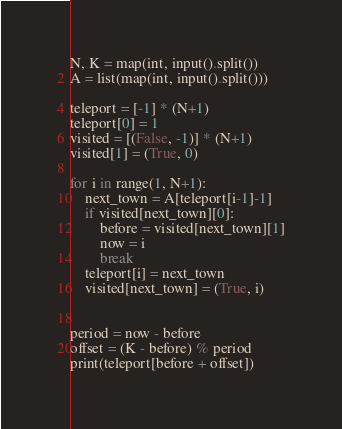Convert code to text. <code><loc_0><loc_0><loc_500><loc_500><_Python_>N, K = map(int, input().split())
A = list(map(int, input().split()))

teleport = [-1] * (N+1)
teleport[0] = 1
visited = [(False, -1)] * (N+1)
visited[1] = (True, 0)

for i in range(1, N+1):
    next_town = A[teleport[i-1]-1]
    if visited[next_town][0]:
        before = visited[next_town][1]
        now = i
        break
    teleport[i] = next_town
    visited[next_town] = (True, i)


period = now - before
offset = (K - before) % period
print(teleport[before + offset])
</code> 